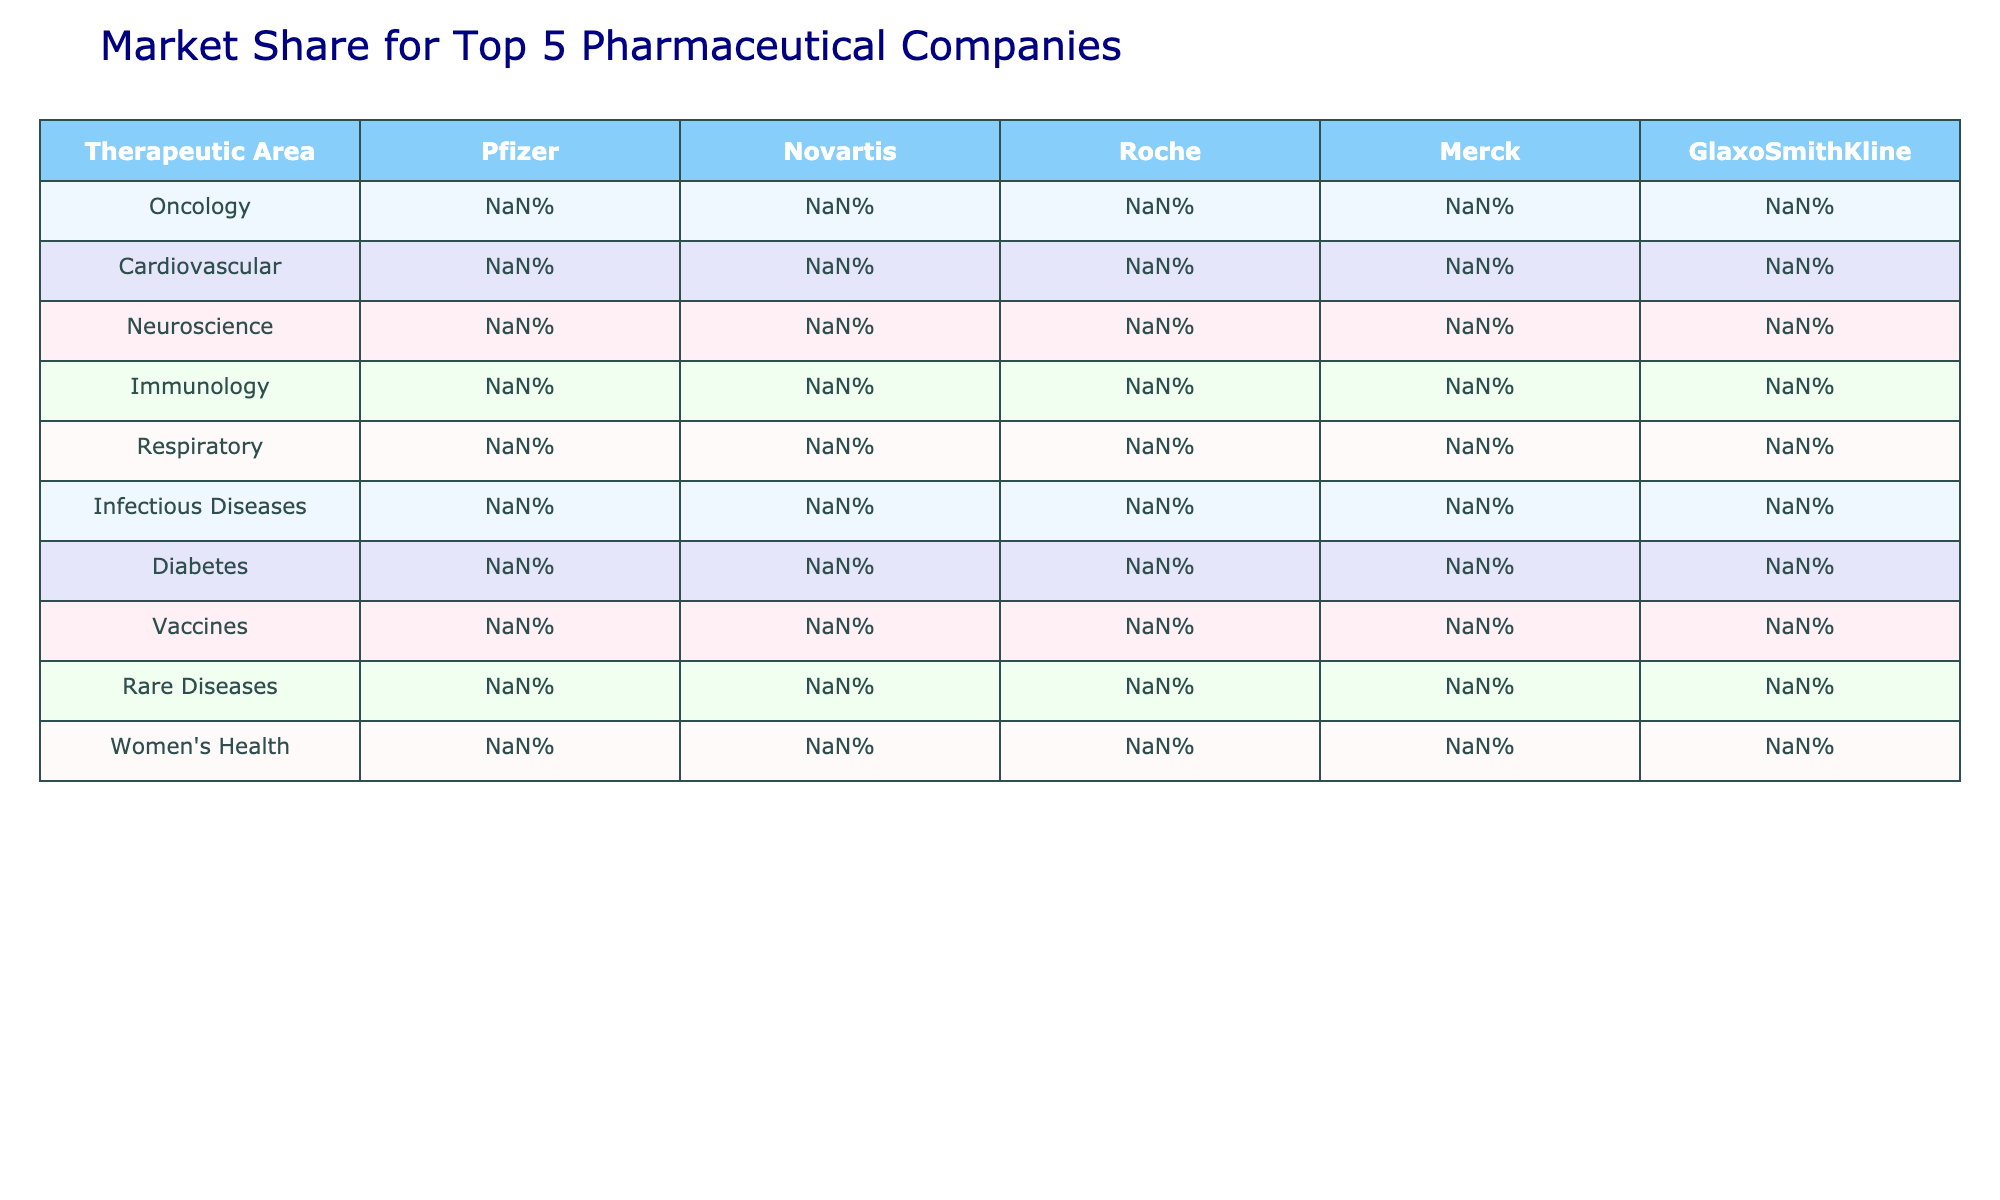What is the market share of Roche in the Oncology therapeutic area? The table indicates that Roche has a market share of 31% in the Oncology therapeutic area.
Answer: 31% Which company has the highest market share in the Cardiovascular therapeutic area? According to the table, Pfizer has the highest market share at 28% in the Cardiovascular therapeutic area.
Answer: Pfizer True or False: Merck has a greater market share in Neuroscience compared to Novartis. In the table, Merck has a market share of 25% in Neuroscience while Novartis has only 11%. Therefore, it is true that Merck's market share is greater.
Answer: True What is the difference in market share between GlaxoSmithKline and Merck in the Infectious Diseases area? GlaxoSmithKline has a market share of 22% and Merck has 24% in Infectious Diseases. The difference is 24% - 22% = 2%.
Answer: 2% What is the average market share of all companies in the Respiratory therapeutic area? The market shares in the Respiratory area are 8%, 13%, 5%, 11%, and 29%. To find the average, sum them up (8 + 13 + 5 + 11 + 29 = 66) and divide by 5, which gives us 66/5 = 13.2%.
Answer: 13.2% Which therapeutic area has the lowest market share for Roche? Looking at the table, Roche has the lowest market share in the Respiratory area at 5%.
Answer: Respiratory How does the market share of Pfizer in Women's Health compare to its market share in Oncology? Pfizer has a market share of 21% in Women's Health and 22% in Oncology. The comparison shows that its market share in Oncology is slightly higher by 1%.
Answer: Higher by 1% What is the total market share of all companies in the Diabetes therapeutic area? The market shares for Diabetes are 12%, 7%, 3%, 31%, and 9% respectively. Adding them up gives us 12% + 7% + 3% + 31% + 9% = 62%.
Answer: 62% Which company has the second highest market share in the Vacines category? The table shows that after GlaxoSmithKline with 32%, Roche has the second highest market share at 0%.
Answer: Roche Is there a therapeutic area where GlaxoSmithKline has the highest market share? Upon reviewing the table, GlaxoSmithKline has the highest market share in Vaccines at 32%. Therefore, the statement is true.
Answer: True What is the combined market share of Merck and Novartis in the Rare Diseases area? The market shares for Rare Diseases are 8% for Merck and 19% for Novartis. Their combined market share is therefore 8% + 19% = 27%.
Answer: 27% 